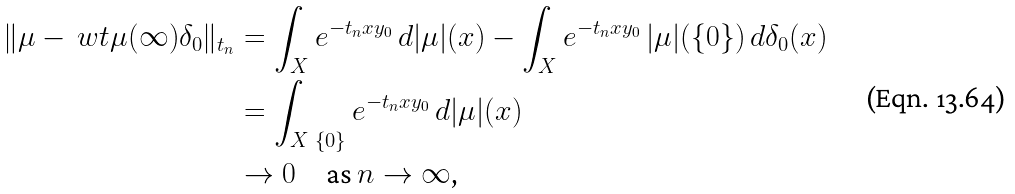Convert formula to latex. <formula><loc_0><loc_0><loc_500><loc_500>\| \mu - \ w t { \mu } ( \infty ) \delta _ { 0 } \| _ { t _ { n } } & = \int _ { X } e ^ { - t _ { n } x y _ { 0 } } \, d | \mu | ( x ) - \int _ { X } e ^ { - t _ { n } x y _ { 0 } } \, | \mu | ( \{ 0 \} ) \, d \delta _ { 0 } ( x ) \\ & = \int _ { X \ \{ 0 \} } e ^ { - t _ { n } x y _ { 0 } } \, d | \mu | ( x ) \\ & \to 0 \quad \text {as $n\to\infty$,}</formula> 